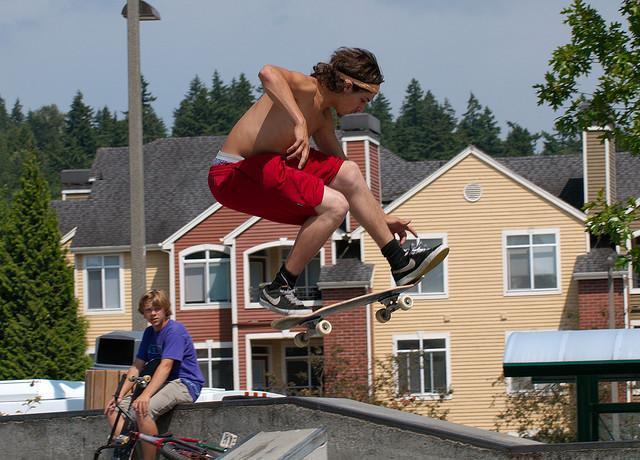What muscle do skater jumps Work?
Make your selection from the four choices given to correctly answer the question.
Options: Shoulder, hand, elbow, rump. Rump. 